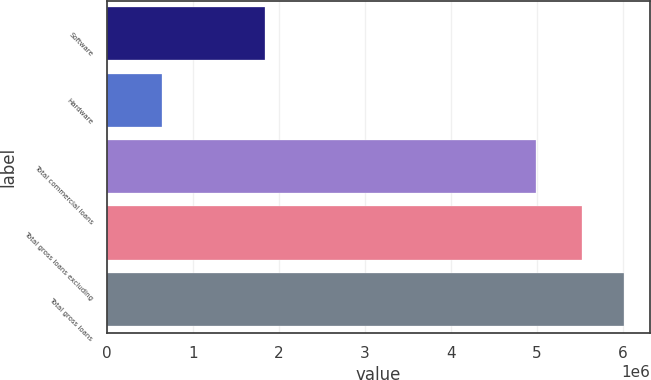Convert chart. <chart><loc_0><loc_0><loc_500><loc_500><bar_chart><fcel>Software<fcel>Hardware<fcel>Total commercial loans<fcel>Total gross loans excluding<fcel>Total gross loans<nl><fcel>1.8349e+06<fcel>642786<fcel>4.99194e+06<fcel>5.52576e+06<fcel>6.01709e+06<nl></chart> 